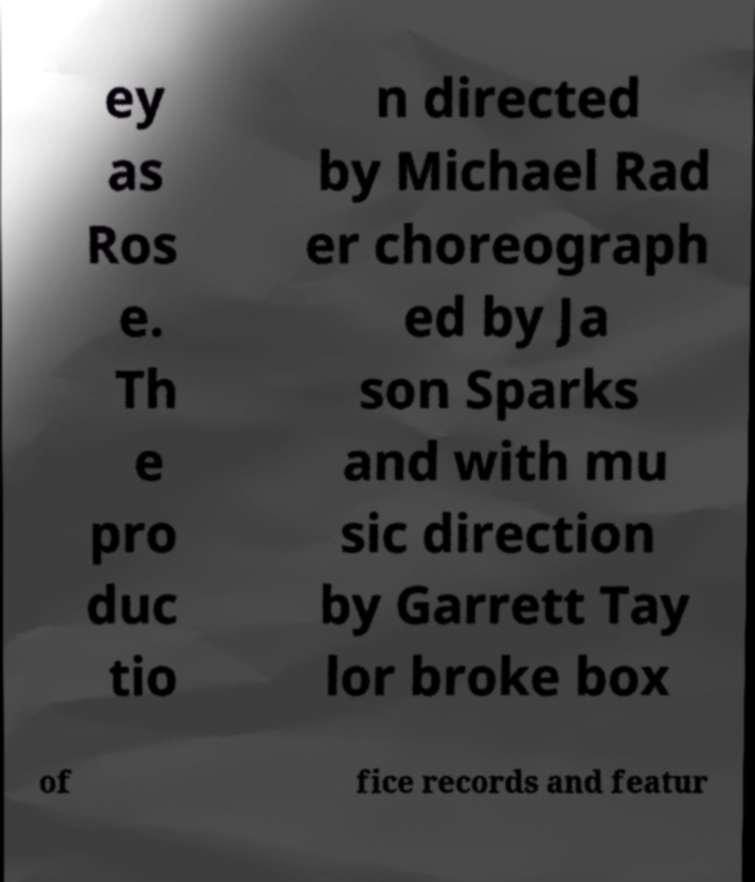What messages or text are displayed in this image? I need them in a readable, typed format. ey as Ros e. Th e pro duc tio n directed by Michael Rad er choreograph ed by Ja son Sparks and with mu sic direction by Garrett Tay lor broke box of fice records and featur 